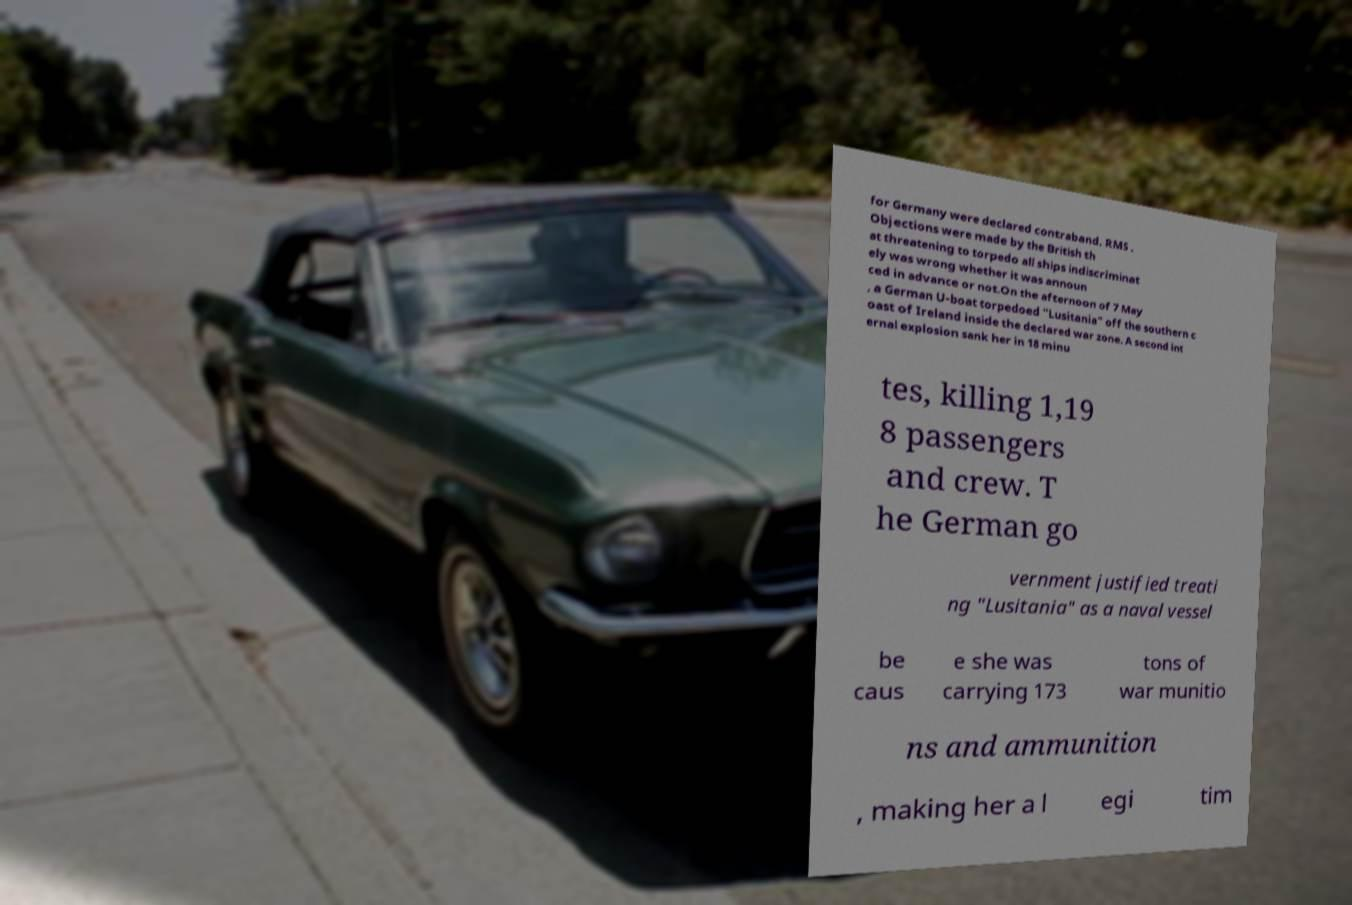For documentation purposes, I need the text within this image transcribed. Could you provide that? for Germany were declared contraband. RMS . Objections were made by the British th at threatening to torpedo all ships indiscriminat ely was wrong whether it was announ ced in advance or not.On the afternoon of 7 May , a German U-boat torpedoed "Lusitania" off the southern c oast of Ireland inside the declared war zone. A second int ernal explosion sank her in 18 minu tes, killing 1,19 8 passengers and crew. T he German go vernment justified treati ng "Lusitania" as a naval vessel be caus e she was carrying 173 tons of war munitio ns and ammunition , making her a l egi tim 